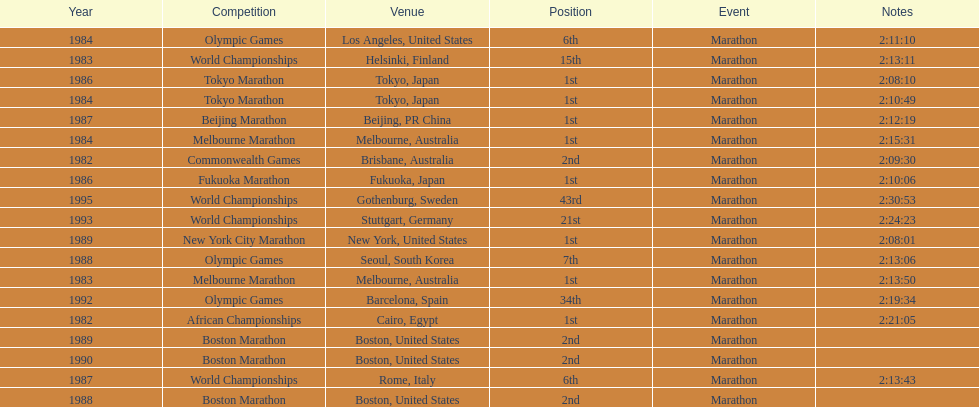In what year did the runner participate in the most marathons? 1984. 